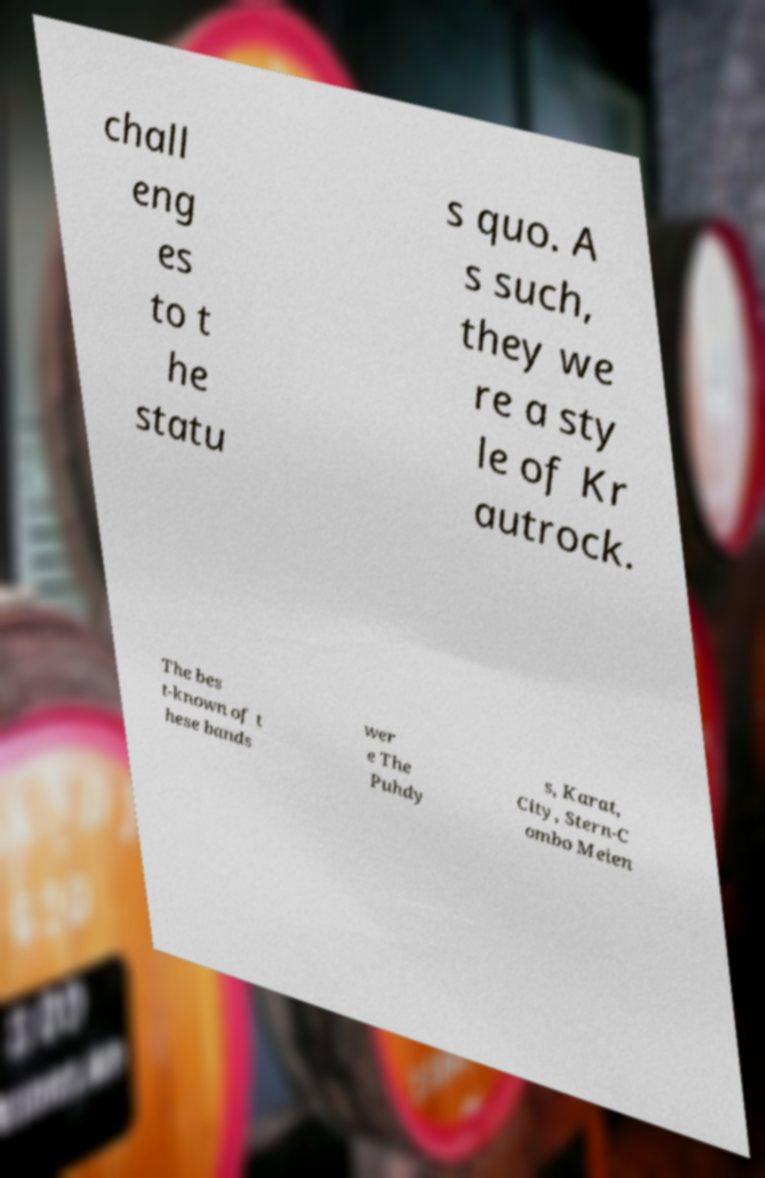There's text embedded in this image that I need extracted. Can you transcribe it verbatim? chall eng es to t he statu s quo. A s such, they we re a sty le of Kr autrock. The bes t-known of t hese bands wer e The Puhdy s, Karat, City, Stern-C ombo Meien 